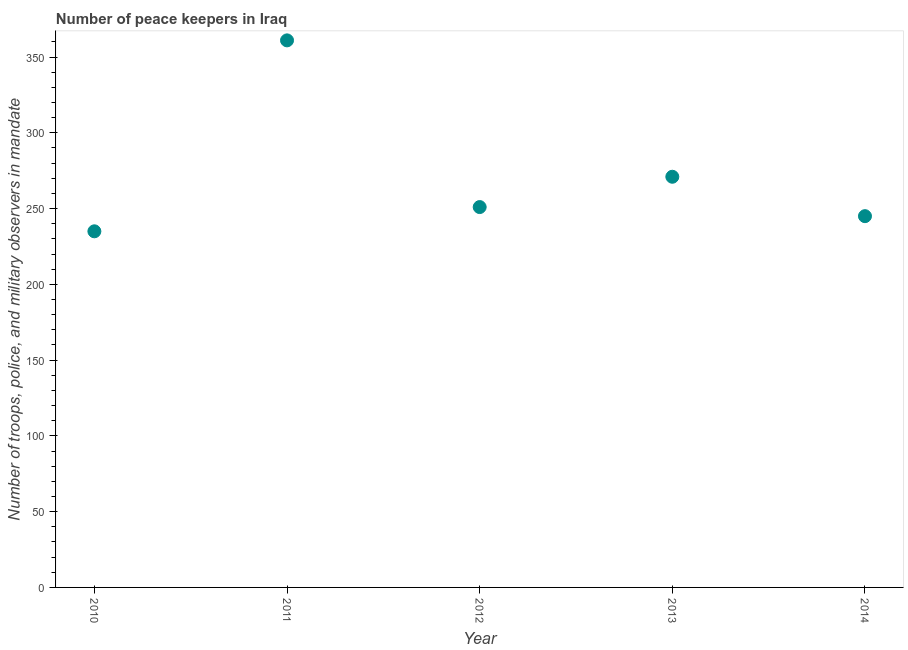What is the number of peace keepers in 2010?
Offer a very short reply. 235. Across all years, what is the maximum number of peace keepers?
Keep it short and to the point. 361. Across all years, what is the minimum number of peace keepers?
Offer a very short reply. 235. In which year was the number of peace keepers minimum?
Offer a very short reply. 2010. What is the sum of the number of peace keepers?
Your answer should be compact. 1363. What is the average number of peace keepers per year?
Your answer should be very brief. 272.6. What is the median number of peace keepers?
Keep it short and to the point. 251. In how many years, is the number of peace keepers greater than 230 ?
Offer a very short reply. 5. What is the ratio of the number of peace keepers in 2011 to that in 2012?
Your response must be concise. 1.44. Is the number of peace keepers in 2011 less than that in 2014?
Give a very brief answer. No. What is the difference between the highest and the second highest number of peace keepers?
Your answer should be very brief. 90. Is the sum of the number of peace keepers in 2011 and 2014 greater than the maximum number of peace keepers across all years?
Provide a succinct answer. Yes. What is the difference between the highest and the lowest number of peace keepers?
Give a very brief answer. 126. In how many years, is the number of peace keepers greater than the average number of peace keepers taken over all years?
Give a very brief answer. 1. How many dotlines are there?
Provide a short and direct response. 1. What is the difference between two consecutive major ticks on the Y-axis?
Provide a short and direct response. 50. What is the title of the graph?
Give a very brief answer. Number of peace keepers in Iraq. What is the label or title of the Y-axis?
Offer a very short reply. Number of troops, police, and military observers in mandate. What is the Number of troops, police, and military observers in mandate in 2010?
Your answer should be compact. 235. What is the Number of troops, police, and military observers in mandate in 2011?
Give a very brief answer. 361. What is the Number of troops, police, and military observers in mandate in 2012?
Your response must be concise. 251. What is the Number of troops, police, and military observers in mandate in 2013?
Make the answer very short. 271. What is the Number of troops, police, and military observers in mandate in 2014?
Keep it short and to the point. 245. What is the difference between the Number of troops, police, and military observers in mandate in 2010 and 2011?
Make the answer very short. -126. What is the difference between the Number of troops, police, and military observers in mandate in 2010 and 2012?
Make the answer very short. -16. What is the difference between the Number of troops, police, and military observers in mandate in 2010 and 2013?
Your answer should be very brief. -36. What is the difference between the Number of troops, police, and military observers in mandate in 2011 and 2012?
Offer a terse response. 110. What is the difference between the Number of troops, police, and military observers in mandate in 2011 and 2014?
Ensure brevity in your answer.  116. What is the difference between the Number of troops, police, and military observers in mandate in 2012 and 2013?
Provide a short and direct response. -20. What is the ratio of the Number of troops, police, and military observers in mandate in 2010 to that in 2011?
Provide a succinct answer. 0.65. What is the ratio of the Number of troops, police, and military observers in mandate in 2010 to that in 2012?
Ensure brevity in your answer.  0.94. What is the ratio of the Number of troops, police, and military observers in mandate in 2010 to that in 2013?
Provide a succinct answer. 0.87. What is the ratio of the Number of troops, police, and military observers in mandate in 2011 to that in 2012?
Your answer should be compact. 1.44. What is the ratio of the Number of troops, police, and military observers in mandate in 2011 to that in 2013?
Make the answer very short. 1.33. What is the ratio of the Number of troops, police, and military observers in mandate in 2011 to that in 2014?
Give a very brief answer. 1.47. What is the ratio of the Number of troops, police, and military observers in mandate in 2012 to that in 2013?
Keep it short and to the point. 0.93. What is the ratio of the Number of troops, police, and military observers in mandate in 2013 to that in 2014?
Keep it short and to the point. 1.11. 